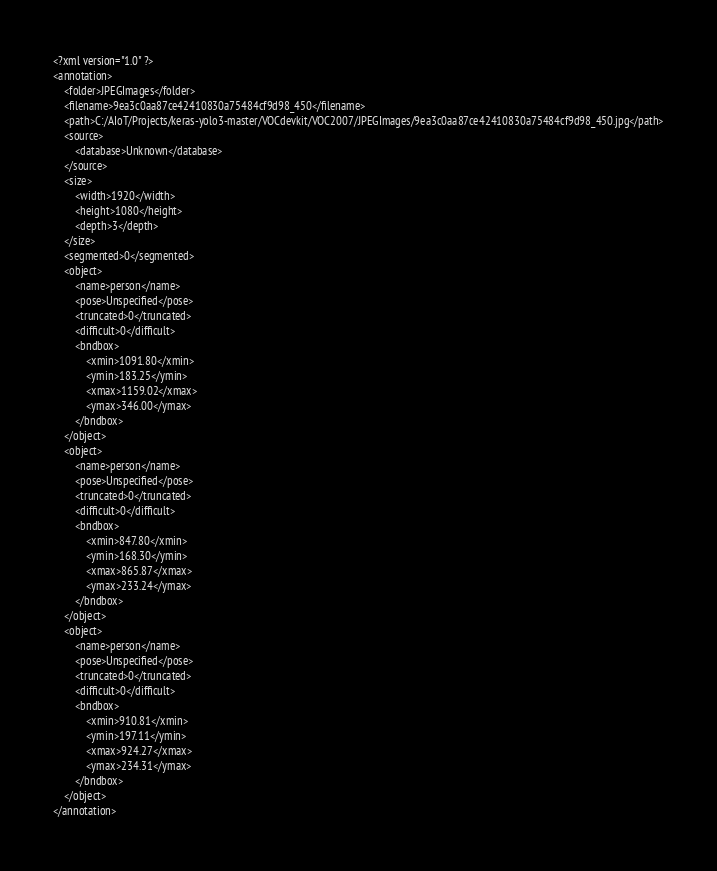<code> <loc_0><loc_0><loc_500><loc_500><_XML_><?xml version="1.0" ?>
<annotation>
	<folder>JPEGImages</folder>
	<filename>9ea3c0aa87ce42410830a75484cf9d98_450</filename>
	<path>C:/AIoT/Projects/keras-yolo3-master/VOCdevkit/VOC2007/JPEGImages/9ea3c0aa87ce42410830a75484cf9d98_450.jpg</path>
	<source>
		<database>Unknown</database>
	</source>
	<size>
		<width>1920</width>
		<height>1080</height>
		<depth>3</depth>
	</size>
	<segmented>0</segmented>
	<object>
		<name>person</name>
		<pose>Unspecified</pose>
		<truncated>0</truncated>
		<difficult>0</difficult>
		<bndbox>
			<xmin>1091.80</xmin>
			<ymin>183.25</ymin>
			<xmax>1159.02</xmax>
			<ymax>346.00</ymax>
		</bndbox>
	</object>
	<object>
		<name>person</name>
		<pose>Unspecified</pose>
		<truncated>0</truncated>
		<difficult>0</difficult>
		<bndbox>
			<xmin>847.80</xmin>
			<ymin>168.30</ymin>
			<xmax>865.87</xmax>
			<ymax>233.24</ymax>
		</bndbox>
	</object>
	<object>
		<name>person</name>
		<pose>Unspecified</pose>
		<truncated>0</truncated>
		<difficult>0</difficult>
		<bndbox>
			<xmin>910.81</xmin>
			<ymin>197.11</ymin>
			<xmax>924.27</xmax>
			<ymax>234.31</ymax>
		</bndbox>
	</object>
</annotation>
</code> 